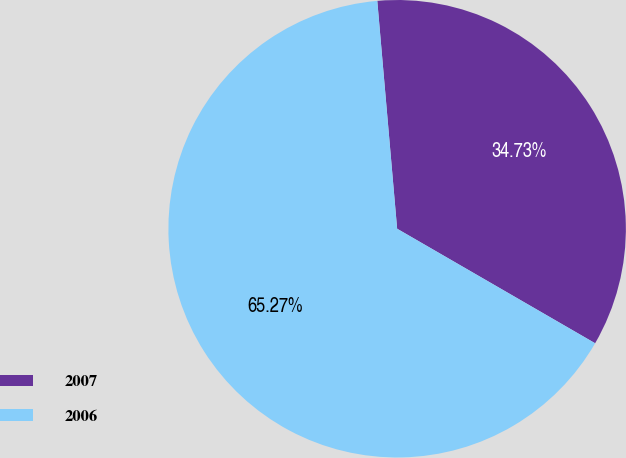Convert chart to OTSL. <chart><loc_0><loc_0><loc_500><loc_500><pie_chart><fcel>2007<fcel>2006<nl><fcel>34.73%<fcel>65.27%<nl></chart> 